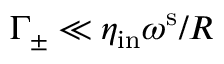<formula> <loc_0><loc_0><loc_500><loc_500>\Gamma _ { \pm } \ll \eta _ { i n } \omega ^ { s } / R</formula> 